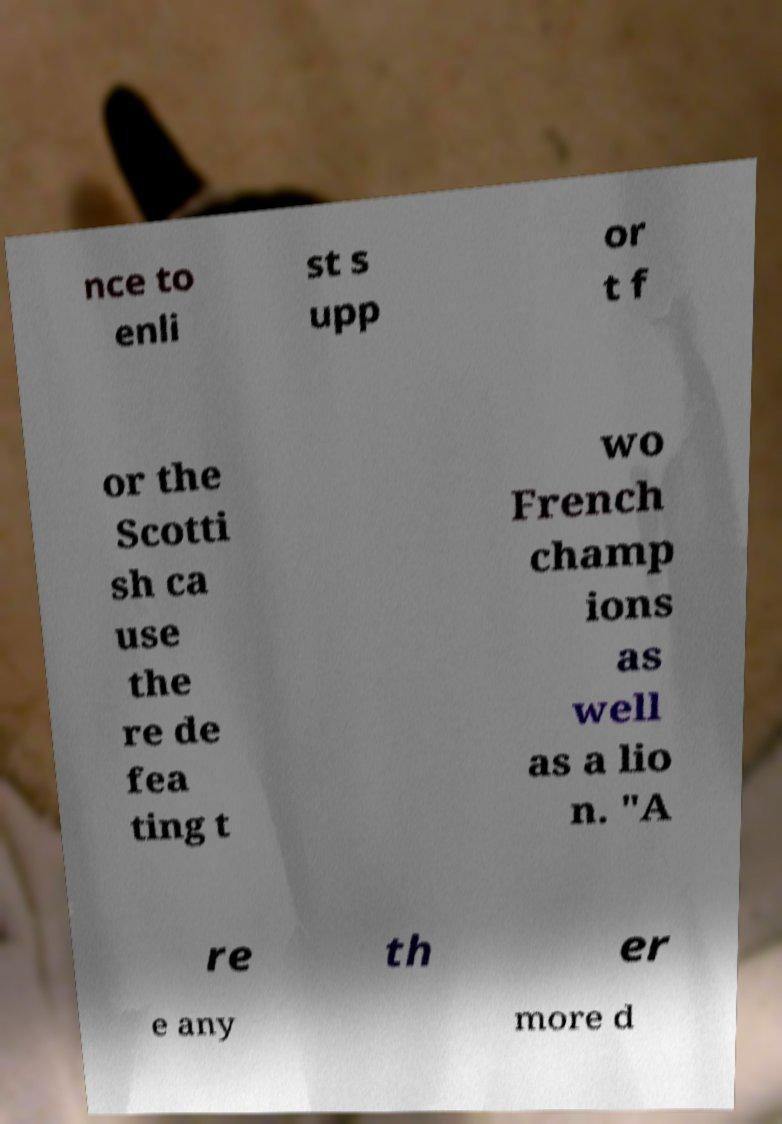There's text embedded in this image that I need extracted. Can you transcribe it verbatim? nce to enli st s upp or t f or the Scotti sh ca use the re de fea ting t wo French champ ions as well as a lio n. "A re th er e any more d 